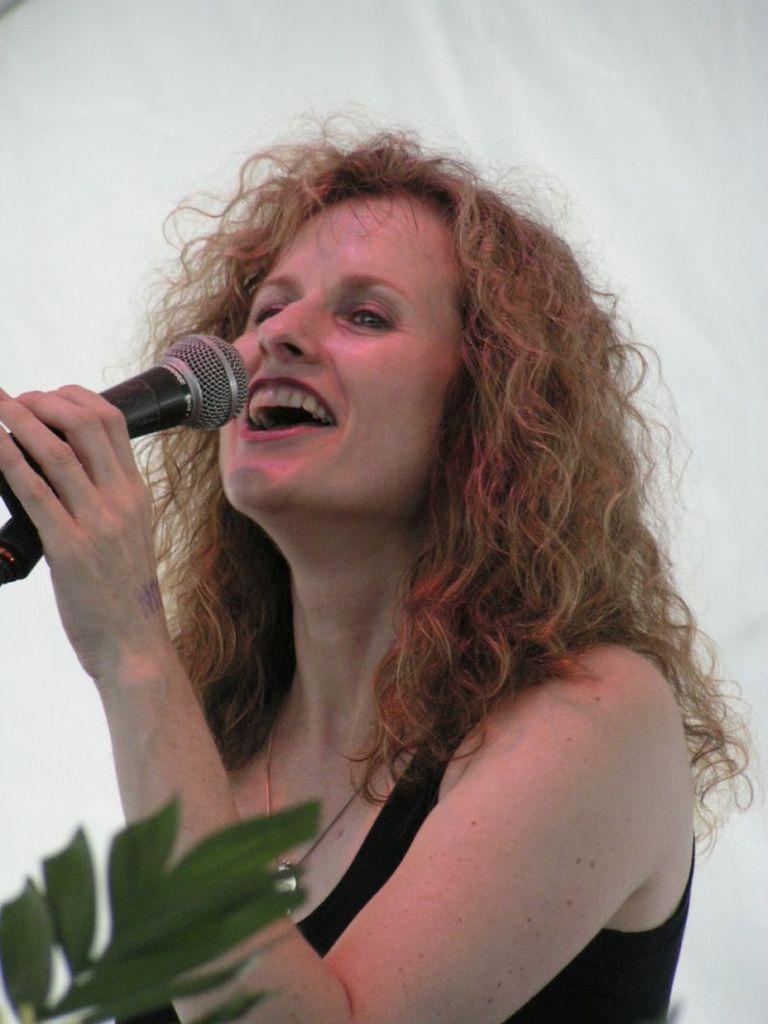Describe this image in one or two sentences. Here we can see a woman singing with a microphone in her hand and at the bottom left we can see leaves 